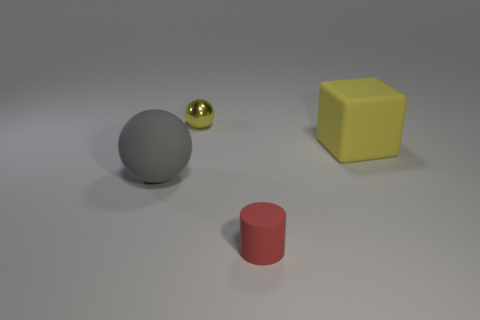What number of other objects are the same size as the block?
Make the answer very short. 1. Is the shape of the object that is in front of the gray matte ball the same as the yellow thing that is in front of the tiny yellow sphere?
Give a very brief answer. No. What number of matte cubes are in front of the cube?
Make the answer very short. 0. The rubber cube that is behind the red cylinder is what color?
Offer a very short reply. Yellow. What is the color of the other large object that is the same shape as the metal thing?
Provide a succinct answer. Gray. Is there any other thing that is the same color as the tiny metal ball?
Give a very brief answer. Yes. Is the number of gray spheres greater than the number of large rubber objects?
Make the answer very short. No. Do the big block and the large sphere have the same material?
Offer a very short reply. Yes. How many big objects have the same material as the big gray sphere?
Your answer should be compact. 1. There is a red object; does it have the same size as the matte thing on the left side of the small rubber object?
Ensure brevity in your answer.  No. 